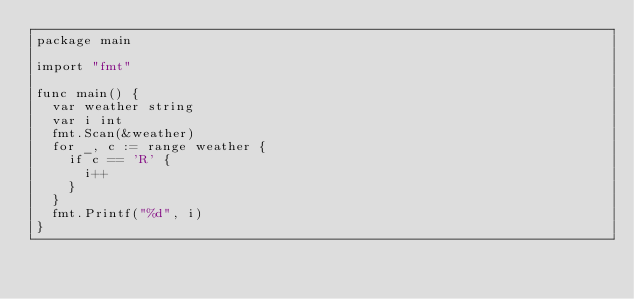Convert code to text. <code><loc_0><loc_0><loc_500><loc_500><_Go_>package main

import "fmt"

func main() {
	var weather string
	var i int
	fmt.Scan(&weather)
	for _, c := range weather {
		if c == 'R' {
			i++
		}
	}
	fmt.Printf("%d", i)
}</code> 